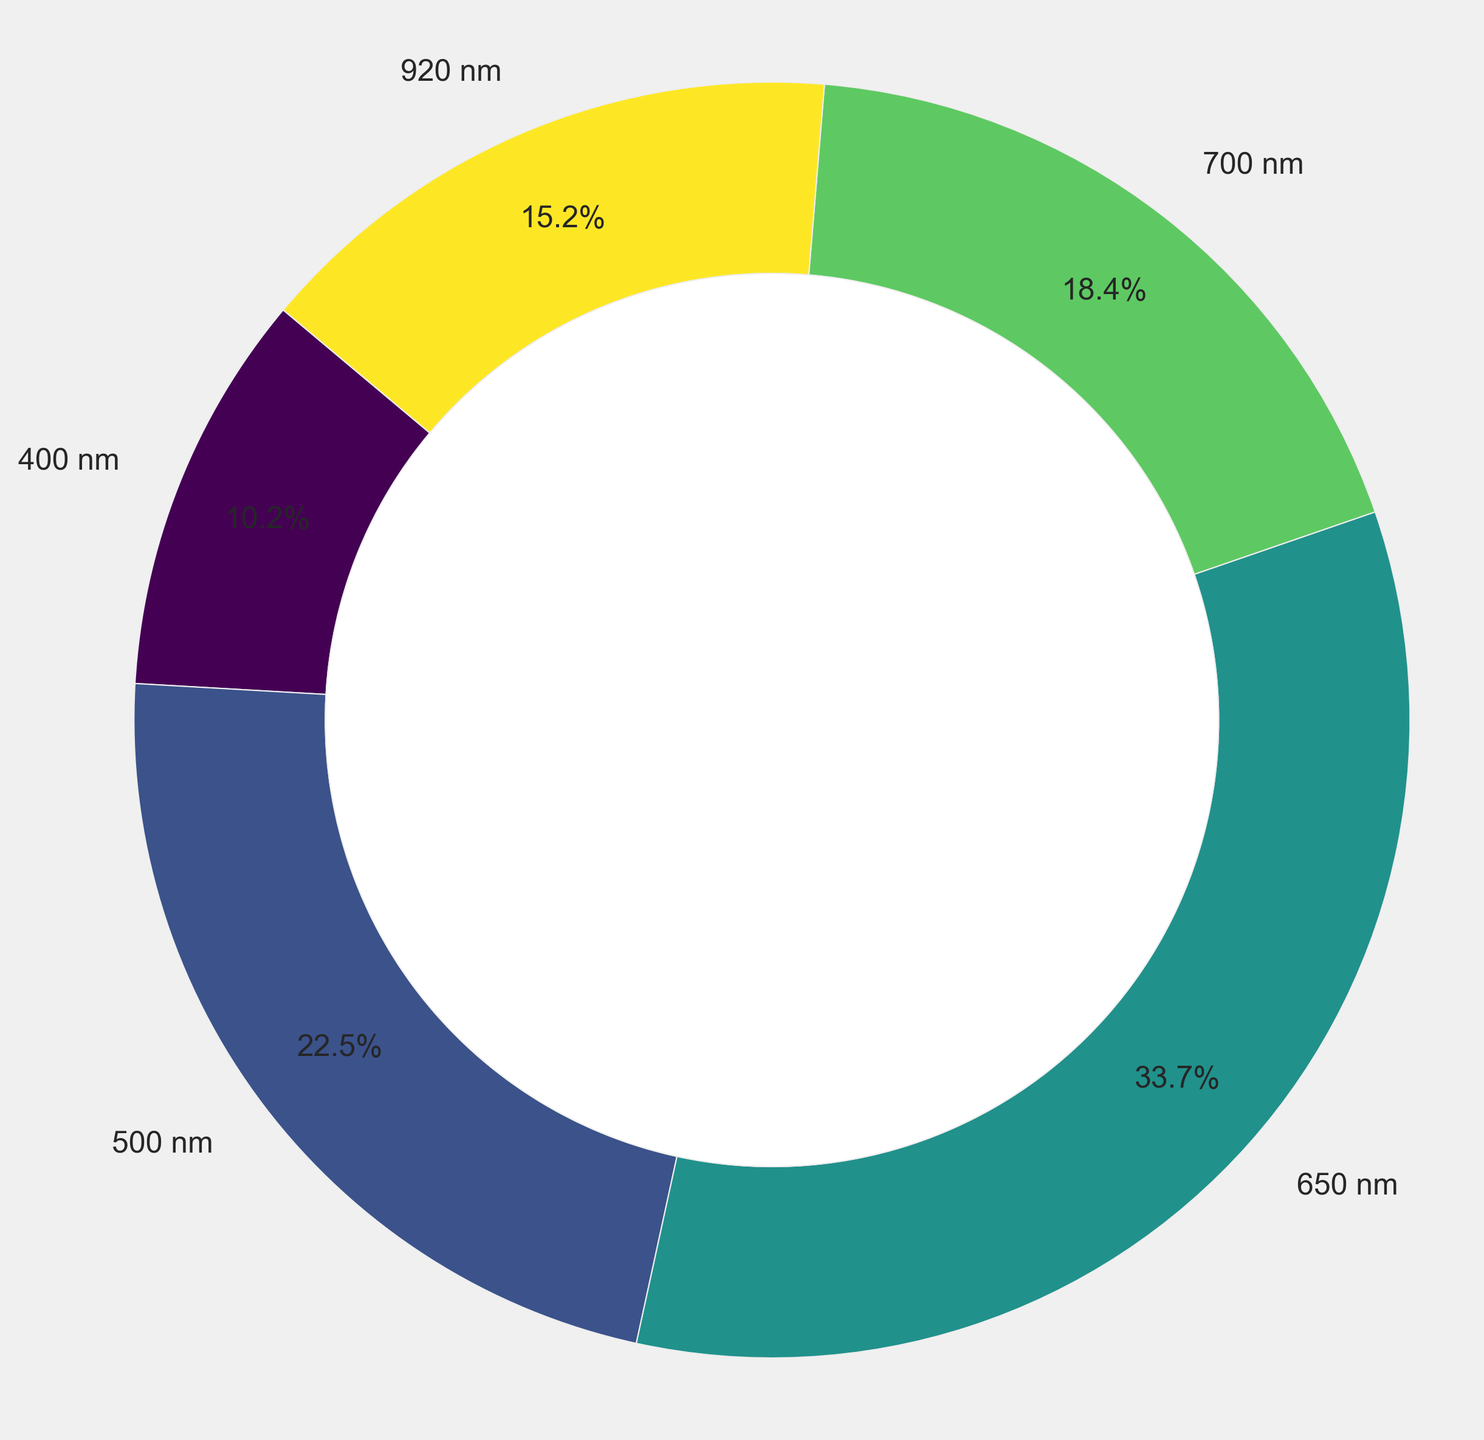What percentage of the light spectrum in the nebulae is found at 500 nm? From the pie chart, we can directly see that the slice labeled "500 nm" takes up 22.5% of the pie.
Answer: 22.5% Which wavelength has the lowest percentage in the light spectrum breakdown? By looking at the pie chart, we can see that the smallest slice corresponds to the label "400 nm" with a percentage of 10.2%.
Answer: 400 nm What is the combined percentage of the wavelengths 400 nm and 700 nm? To find the combined percentage, we add the percentages for the two wavelengths: 10.2% (400 nm) + 18.4% (700 nm) = 28.6%.
Answer: 28.6% Which wavelength has a higher percentage: 650 nm or 920 nm? By comparing the two slices, we see that the 650 nm wavelength has a percentage of 33.7% whereas the 920 nm wavelength has a percentage of 15.2%. Therefore, 650 nm has a higher percentage.
Answer: 650 nm How much more percentage does the 650 nm wavelength have compared to the 700 nm wavelength? To determine this, we subtract the percentage for 700 nm from that of 650 nm: 33.7% - 18.4% = 15.3%.
Answer: 15.3% What is the average percentage of all the light spectrum frequencies in the nebulae? To find the average, sum all the percentages and divide by the number of wavelengths: (10.2% + 22.5% + 33.7% + 18.4% + 15.2%) / 5 = 20%.
Answer: 20% Which wavelength represents the largest portion of the light spectrum breakdown? From the pie chart, the largest slice corresponds to "650 nm" with a percentage of 33.7%.
Answer: 650 nm How do the percentages of 500 nm and 920 nm compare? The pie chart shows that 500 nm has a percentage of 22.5%, while 920 nm has 15.2%, indicating that 500 nm has a higher percentage than 920 nm.
Answer: 500 nm has a higher percentage What is the total percentage of wavelengths greater than 600 nm? We add the percentages of 650 nm, 700 nm, and 920 nm: 33.7% + 18.4% + 15.2% = 67.3%.
Answer: 67.3% What is the difference in percentage between the smallest and largest wavelength slices? The smallest slice is for 400 nm with 10.2%, and the largest slice is for 650 nm with 33.7%. The difference is 33.7% - 10.2% = 23.5%.
Answer: 23.5% 